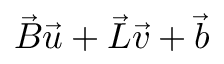Convert formula to latex. <formula><loc_0><loc_0><loc_500><loc_500>\vec { B } \vec { u } + \vec { L } \vec { v } + \vec { b }</formula> 